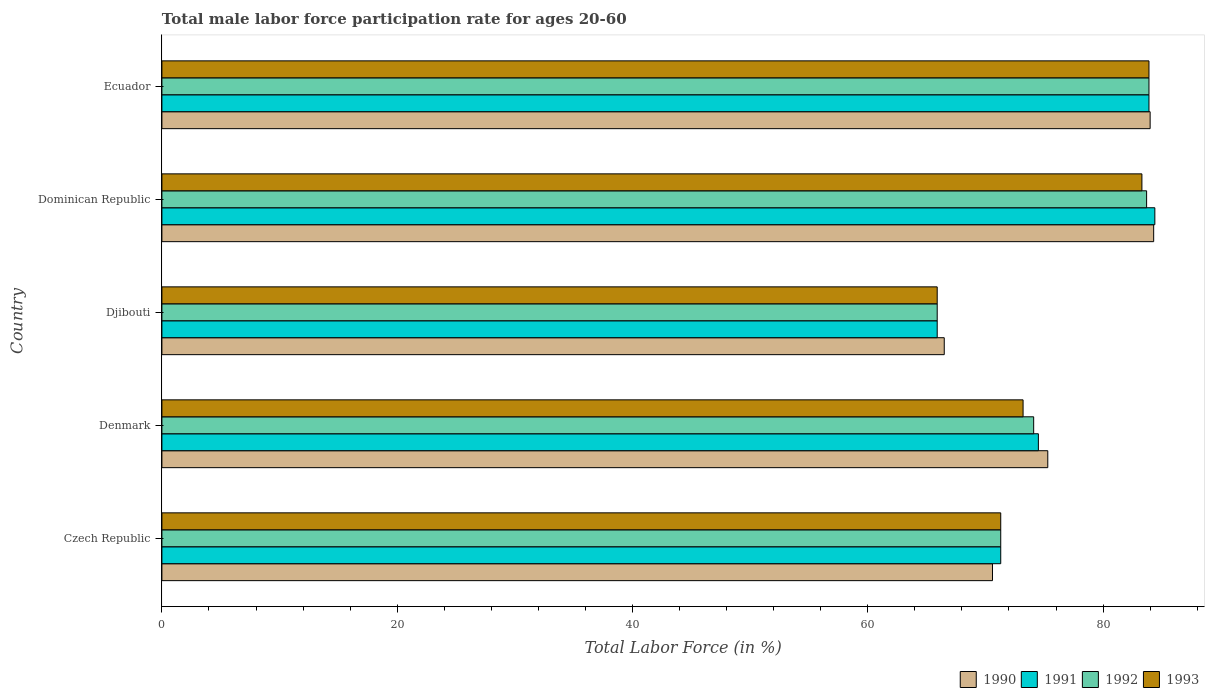Are the number of bars per tick equal to the number of legend labels?
Offer a very short reply. Yes. How many bars are there on the 3rd tick from the bottom?
Ensure brevity in your answer.  4. What is the male labor force participation rate in 1990 in Denmark?
Provide a succinct answer. 75.3. Across all countries, what is the maximum male labor force participation rate in 1991?
Your answer should be compact. 84.4. Across all countries, what is the minimum male labor force participation rate in 1992?
Give a very brief answer. 65.9. In which country was the male labor force participation rate in 1990 maximum?
Offer a terse response. Dominican Republic. In which country was the male labor force participation rate in 1991 minimum?
Make the answer very short. Djibouti. What is the total male labor force participation rate in 1993 in the graph?
Give a very brief answer. 377.6. What is the difference between the male labor force participation rate in 1993 in Dominican Republic and that in Ecuador?
Provide a succinct answer. -0.6. What is the difference between the male labor force participation rate in 1993 in Dominican Republic and the male labor force participation rate in 1990 in Czech Republic?
Make the answer very short. 12.7. What is the average male labor force participation rate in 1990 per country?
Ensure brevity in your answer.  76.14. What is the difference between the male labor force participation rate in 1991 and male labor force participation rate in 1993 in Dominican Republic?
Your answer should be compact. 1.1. What is the ratio of the male labor force participation rate in 1990 in Denmark to that in Dominican Republic?
Give a very brief answer. 0.89. Is the male labor force participation rate in 1992 in Djibouti less than that in Ecuador?
Offer a very short reply. Yes. Is the difference between the male labor force participation rate in 1991 in Dominican Republic and Ecuador greater than the difference between the male labor force participation rate in 1993 in Dominican Republic and Ecuador?
Offer a terse response. Yes. What is the difference between the highest and the second highest male labor force participation rate in 1991?
Offer a very short reply. 0.5. What is the difference between the highest and the lowest male labor force participation rate in 1992?
Ensure brevity in your answer.  18. In how many countries, is the male labor force participation rate in 1993 greater than the average male labor force participation rate in 1993 taken over all countries?
Offer a very short reply. 2. Is it the case that in every country, the sum of the male labor force participation rate in 1992 and male labor force participation rate in 1991 is greater than the sum of male labor force participation rate in 1993 and male labor force participation rate in 1990?
Your response must be concise. No. What does the 4th bar from the bottom in Ecuador represents?
Your answer should be compact. 1993. Is it the case that in every country, the sum of the male labor force participation rate in 1992 and male labor force participation rate in 1993 is greater than the male labor force participation rate in 1990?
Offer a terse response. Yes. How many countries are there in the graph?
Ensure brevity in your answer.  5. Where does the legend appear in the graph?
Provide a succinct answer. Bottom right. What is the title of the graph?
Your response must be concise. Total male labor force participation rate for ages 20-60. What is the label or title of the X-axis?
Provide a short and direct response. Total Labor Force (in %). What is the Total Labor Force (in %) of 1990 in Czech Republic?
Your response must be concise. 70.6. What is the Total Labor Force (in %) of 1991 in Czech Republic?
Offer a very short reply. 71.3. What is the Total Labor Force (in %) in 1992 in Czech Republic?
Your response must be concise. 71.3. What is the Total Labor Force (in %) in 1993 in Czech Republic?
Your answer should be compact. 71.3. What is the Total Labor Force (in %) of 1990 in Denmark?
Keep it short and to the point. 75.3. What is the Total Labor Force (in %) in 1991 in Denmark?
Offer a very short reply. 74.5. What is the Total Labor Force (in %) in 1992 in Denmark?
Give a very brief answer. 74.1. What is the Total Labor Force (in %) in 1993 in Denmark?
Your response must be concise. 73.2. What is the Total Labor Force (in %) in 1990 in Djibouti?
Offer a terse response. 66.5. What is the Total Labor Force (in %) in 1991 in Djibouti?
Give a very brief answer. 65.9. What is the Total Labor Force (in %) in 1992 in Djibouti?
Your response must be concise. 65.9. What is the Total Labor Force (in %) of 1993 in Djibouti?
Make the answer very short. 65.9. What is the Total Labor Force (in %) in 1990 in Dominican Republic?
Offer a very short reply. 84.3. What is the Total Labor Force (in %) in 1991 in Dominican Republic?
Give a very brief answer. 84.4. What is the Total Labor Force (in %) in 1992 in Dominican Republic?
Keep it short and to the point. 83.7. What is the Total Labor Force (in %) of 1993 in Dominican Republic?
Offer a very short reply. 83.3. What is the Total Labor Force (in %) of 1990 in Ecuador?
Give a very brief answer. 84. What is the Total Labor Force (in %) of 1991 in Ecuador?
Keep it short and to the point. 83.9. What is the Total Labor Force (in %) in 1992 in Ecuador?
Your response must be concise. 83.9. What is the Total Labor Force (in %) in 1993 in Ecuador?
Provide a short and direct response. 83.9. Across all countries, what is the maximum Total Labor Force (in %) of 1990?
Offer a terse response. 84.3. Across all countries, what is the maximum Total Labor Force (in %) in 1991?
Your answer should be very brief. 84.4. Across all countries, what is the maximum Total Labor Force (in %) of 1992?
Give a very brief answer. 83.9. Across all countries, what is the maximum Total Labor Force (in %) in 1993?
Offer a very short reply. 83.9. Across all countries, what is the minimum Total Labor Force (in %) of 1990?
Your answer should be compact. 66.5. Across all countries, what is the minimum Total Labor Force (in %) in 1991?
Offer a very short reply. 65.9. Across all countries, what is the minimum Total Labor Force (in %) in 1992?
Give a very brief answer. 65.9. Across all countries, what is the minimum Total Labor Force (in %) in 1993?
Make the answer very short. 65.9. What is the total Total Labor Force (in %) in 1990 in the graph?
Provide a short and direct response. 380.7. What is the total Total Labor Force (in %) of 1991 in the graph?
Your answer should be very brief. 380. What is the total Total Labor Force (in %) of 1992 in the graph?
Make the answer very short. 378.9. What is the total Total Labor Force (in %) of 1993 in the graph?
Provide a short and direct response. 377.6. What is the difference between the Total Labor Force (in %) of 1990 in Czech Republic and that in Denmark?
Provide a short and direct response. -4.7. What is the difference between the Total Labor Force (in %) in 1990 in Czech Republic and that in Djibouti?
Your response must be concise. 4.1. What is the difference between the Total Labor Force (in %) of 1992 in Czech Republic and that in Djibouti?
Your answer should be compact. 5.4. What is the difference between the Total Labor Force (in %) in 1993 in Czech Republic and that in Djibouti?
Keep it short and to the point. 5.4. What is the difference between the Total Labor Force (in %) in 1990 in Czech Republic and that in Dominican Republic?
Make the answer very short. -13.7. What is the difference between the Total Labor Force (in %) in 1993 in Czech Republic and that in Dominican Republic?
Offer a very short reply. -12. What is the difference between the Total Labor Force (in %) of 1992 in Czech Republic and that in Ecuador?
Your response must be concise. -12.6. What is the difference between the Total Labor Force (in %) in 1993 in Czech Republic and that in Ecuador?
Your answer should be very brief. -12.6. What is the difference between the Total Labor Force (in %) of 1992 in Denmark and that in Djibouti?
Ensure brevity in your answer.  8.2. What is the difference between the Total Labor Force (in %) of 1990 in Denmark and that in Dominican Republic?
Give a very brief answer. -9. What is the difference between the Total Labor Force (in %) of 1991 in Denmark and that in Dominican Republic?
Offer a very short reply. -9.9. What is the difference between the Total Labor Force (in %) of 1992 in Denmark and that in Dominican Republic?
Your answer should be very brief. -9.6. What is the difference between the Total Labor Force (in %) of 1993 in Denmark and that in Dominican Republic?
Offer a terse response. -10.1. What is the difference between the Total Labor Force (in %) in 1990 in Denmark and that in Ecuador?
Provide a succinct answer. -8.7. What is the difference between the Total Labor Force (in %) of 1992 in Denmark and that in Ecuador?
Provide a short and direct response. -9.8. What is the difference between the Total Labor Force (in %) in 1993 in Denmark and that in Ecuador?
Your answer should be very brief. -10.7. What is the difference between the Total Labor Force (in %) in 1990 in Djibouti and that in Dominican Republic?
Make the answer very short. -17.8. What is the difference between the Total Labor Force (in %) in 1991 in Djibouti and that in Dominican Republic?
Offer a terse response. -18.5. What is the difference between the Total Labor Force (in %) in 1992 in Djibouti and that in Dominican Republic?
Offer a very short reply. -17.8. What is the difference between the Total Labor Force (in %) of 1993 in Djibouti and that in Dominican Republic?
Provide a succinct answer. -17.4. What is the difference between the Total Labor Force (in %) of 1990 in Djibouti and that in Ecuador?
Keep it short and to the point. -17.5. What is the difference between the Total Labor Force (in %) of 1992 in Djibouti and that in Ecuador?
Give a very brief answer. -18. What is the difference between the Total Labor Force (in %) in 1993 in Djibouti and that in Ecuador?
Offer a terse response. -18. What is the difference between the Total Labor Force (in %) in 1990 in Dominican Republic and that in Ecuador?
Make the answer very short. 0.3. What is the difference between the Total Labor Force (in %) in 1991 in Dominican Republic and that in Ecuador?
Your answer should be very brief. 0.5. What is the difference between the Total Labor Force (in %) of 1990 in Czech Republic and the Total Labor Force (in %) of 1992 in Denmark?
Your answer should be very brief. -3.5. What is the difference between the Total Labor Force (in %) in 1991 in Czech Republic and the Total Labor Force (in %) in 1993 in Denmark?
Your answer should be compact. -1.9. What is the difference between the Total Labor Force (in %) of 1992 in Czech Republic and the Total Labor Force (in %) of 1993 in Denmark?
Your answer should be compact. -1.9. What is the difference between the Total Labor Force (in %) in 1990 in Czech Republic and the Total Labor Force (in %) in 1991 in Djibouti?
Make the answer very short. 4.7. What is the difference between the Total Labor Force (in %) in 1990 in Czech Republic and the Total Labor Force (in %) in 1992 in Djibouti?
Provide a short and direct response. 4.7. What is the difference between the Total Labor Force (in %) of 1990 in Czech Republic and the Total Labor Force (in %) of 1993 in Djibouti?
Make the answer very short. 4.7. What is the difference between the Total Labor Force (in %) of 1991 in Czech Republic and the Total Labor Force (in %) of 1992 in Djibouti?
Give a very brief answer. 5.4. What is the difference between the Total Labor Force (in %) of 1991 in Czech Republic and the Total Labor Force (in %) of 1993 in Djibouti?
Provide a short and direct response. 5.4. What is the difference between the Total Labor Force (in %) of 1992 in Czech Republic and the Total Labor Force (in %) of 1993 in Djibouti?
Make the answer very short. 5.4. What is the difference between the Total Labor Force (in %) of 1990 in Czech Republic and the Total Labor Force (in %) of 1992 in Dominican Republic?
Your response must be concise. -13.1. What is the difference between the Total Labor Force (in %) of 1991 in Czech Republic and the Total Labor Force (in %) of 1992 in Dominican Republic?
Make the answer very short. -12.4. What is the difference between the Total Labor Force (in %) of 1991 in Czech Republic and the Total Labor Force (in %) of 1993 in Dominican Republic?
Offer a terse response. -12. What is the difference between the Total Labor Force (in %) in 1990 in Czech Republic and the Total Labor Force (in %) in 1991 in Ecuador?
Make the answer very short. -13.3. What is the difference between the Total Labor Force (in %) in 1991 in Czech Republic and the Total Labor Force (in %) in 1992 in Ecuador?
Provide a short and direct response. -12.6. What is the difference between the Total Labor Force (in %) in 1990 in Denmark and the Total Labor Force (in %) in 1991 in Djibouti?
Your response must be concise. 9.4. What is the difference between the Total Labor Force (in %) in 1990 in Denmark and the Total Labor Force (in %) in 1992 in Dominican Republic?
Your response must be concise. -8.4. What is the difference between the Total Labor Force (in %) of 1991 in Denmark and the Total Labor Force (in %) of 1993 in Dominican Republic?
Ensure brevity in your answer.  -8.8. What is the difference between the Total Labor Force (in %) in 1992 in Denmark and the Total Labor Force (in %) in 1993 in Dominican Republic?
Provide a short and direct response. -9.2. What is the difference between the Total Labor Force (in %) of 1990 in Denmark and the Total Labor Force (in %) of 1993 in Ecuador?
Ensure brevity in your answer.  -8.6. What is the difference between the Total Labor Force (in %) in 1990 in Djibouti and the Total Labor Force (in %) in 1991 in Dominican Republic?
Provide a short and direct response. -17.9. What is the difference between the Total Labor Force (in %) of 1990 in Djibouti and the Total Labor Force (in %) of 1992 in Dominican Republic?
Your answer should be very brief. -17.2. What is the difference between the Total Labor Force (in %) in 1990 in Djibouti and the Total Labor Force (in %) in 1993 in Dominican Republic?
Offer a terse response. -16.8. What is the difference between the Total Labor Force (in %) in 1991 in Djibouti and the Total Labor Force (in %) in 1992 in Dominican Republic?
Your answer should be compact. -17.8. What is the difference between the Total Labor Force (in %) in 1991 in Djibouti and the Total Labor Force (in %) in 1993 in Dominican Republic?
Keep it short and to the point. -17.4. What is the difference between the Total Labor Force (in %) of 1992 in Djibouti and the Total Labor Force (in %) of 1993 in Dominican Republic?
Give a very brief answer. -17.4. What is the difference between the Total Labor Force (in %) in 1990 in Djibouti and the Total Labor Force (in %) in 1991 in Ecuador?
Ensure brevity in your answer.  -17.4. What is the difference between the Total Labor Force (in %) of 1990 in Djibouti and the Total Labor Force (in %) of 1992 in Ecuador?
Ensure brevity in your answer.  -17.4. What is the difference between the Total Labor Force (in %) in 1990 in Djibouti and the Total Labor Force (in %) in 1993 in Ecuador?
Keep it short and to the point. -17.4. What is the difference between the Total Labor Force (in %) in 1991 in Djibouti and the Total Labor Force (in %) in 1992 in Ecuador?
Your answer should be very brief. -18. What is the difference between the Total Labor Force (in %) in 1990 in Dominican Republic and the Total Labor Force (in %) in 1991 in Ecuador?
Offer a very short reply. 0.4. What is the difference between the Total Labor Force (in %) in 1990 in Dominican Republic and the Total Labor Force (in %) in 1992 in Ecuador?
Your answer should be very brief. 0.4. What is the difference between the Total Labor Force (in %) of 1990 in Dominican Republic and the Total Labor Force (in %) of 1993 in Ecuador?
Ensure brevity in your answer.  0.4. What is the average Total Labor Force (in %) in 1990 per country?
Provide a succinct answer. 76.14. What is the average Total Labor Force (in %) of 1992 per country?
Ensure brevity in your answer.  75.78. What is the average Total Labor Force (in %) of 1993 per country?
Offer a very short reply. 75.52. What is the difference between the Total Labor Force (in %) in 1990 and Total Labor Force (in %) in 1991 in Czech Republic?
Give a very brief answer. -0.7. What is the difference between the Total Labor Force (in %) in 1991 and Total Labor Force (in %) in 1993 in Czech Republic?
Offer a very short reply. 0. What is the difference between the Total Labor Force (in %) of 1990 and Total Labor Force (in %) of 1993 in Denmark?
Your response must be concise. 2.1. What is the difference between the Total Labor Force (in %) in 1991 and Total Labor Force (in %) in 1992 in Denmark?
Give a very brief answer. 0.4. What is the difference between the Total Labor Force (in %) of 1991 and Total Labor Force (in %) of 1993 in Denmark?
Your answer should be compact. 1.3. What is the difference between the Total Labor Force (in %) in 1990 and Total Labor Force (in %) in 1993 in Djibouti?
Offer a very short reply. 0.6. What is the difference between the Total Labor Force (in %) in 1991 and Total Labor Force (in %) in 1992 in Djibouti?
Your answer should be very brief. 0. What is the difference between the Total Labor Force (in %) of 1992 and Total Labor Force (in %) of 1993 in Djibouti?
Your response must be concise. 0. What is the difference between the Total Labor Force (in %) of 1990 and Total Labor Force (in %) of 1993 in Dominican Republic?
Make the answer very short. 1. What is the difference between the Total Labor Force (in %) in 1991 and Total Labor Force (in %) in 1993 in Dominican Republic?
Make the answer very short. 1.1. What is the difference between the Total Labor Force (in %) of 1992 and Total Labor Force (in %) of 1993 in Dominican Republic?
Make the answer very short. 0.4. What is the difference between the Total Labor Force (in %) in 1990 and Total Labor Force (in %) in 1992 in Ecuador?
Provide a succinct answer. 0.1. What is the difference between the Total Labor Force (in %) in 1991 and Total Labor Force (in %) in 1992 in Ecuador?
Offer a terse response. 0. What is the difference between the Total Labor Force (in %) of 1991 and Total Labor Force (in %) of 1993 in Ecuador?
Your answer should be very brief. 0. What is the difference between the Total Labor Force (in %) of 1992 and Total Labor Force (in %) of 1993 in Ecuador?
Give a very brief answer. 0. What is the ratio of the Total Labor Force (in %) in 1990 in Czech Republic to that in Denmark?
Your answer should be compact. 0.94. What is the ratio of the Total Labor Force (in %) of 1992 in Czech Republic to that in Denmark?
Your response must be concise. 0.96. What is the ratio of the Total Labor Force (in %) in 1990 in Czech Republic to that in Djibouti?
Your answer should be compact. 1.06. What is the ratio of the Total Labor Force (in %) in 1991 in Czech Republic to that in Djibouti?
Provide a short and direct response. 1.08. What is the ratio of the Total Labor Force (in %) of 1992 in Czech Republic to that in Djibouti?
Your response must be concise. 1.08. What is the ratio of the Total Labor Force (in %) of 1993 in Czech Republic to that in Djibouti?
Your answer should be very brief. 1.08. What is the ratio of the Total Labor Force (in %) in 1990 in Czech Republic to that in Dominican Republic?
Offer a terse response. 0.84. What is the ratio of the Total Labor Force (in %) of 1991 in Czech Republic to that in Dominican Republic?
Provide a succinct answer. 0.84. What is the ratio of the Total Labor Force (in %) of 1992 in Czech Republic to that in Dominican Republic?
Offer a terse response. 0.85. What is the ratio of the Total Labor Force (in %) of 1993 in Czech Republic to that in Dominican Republic?
Give a very brief answer. 0.86. What is the ratio of the Total Labor Force (in %) in 1990 in Czech Republic to that in Ecuador?
Give a very brief answer. 0.84. What is the ratio of the Total Labor Force (in %) in 1991 in Czech Republic to that in Ecuador?
Provide a short and direct response. 0.85. What is the ratio of the Total Labor Force (in %) of 1992 in Czech Republic to that in Ecuador?
Offer a very short reply. 0.85. What is the ratio of the Total Labor Force (in %) of 1993 in Czech Republic to that in Ecuador?
Your answer should be compact. 0.85. What is the ratio of the Total Labor Force (in %) of 1990 in Denmark to that in Djibouti?
Make the answer very short. 1.13. What is the ratio of the Total Labor Force (in %) of 1991 in Denmark to that in Djibouti?
Your answer should be compact. 1.13. What is the ratio of the Total Labor Force (in %) of 1992 in Denmark to that in Djibouti?
Your answer should be very brief. 1.12. What is the ratio of the Total Labor Force (in %) of 1993 in Denmark to that in Djibouti?
Offer a very short reply. 1.11. What is the ratio of the Total Labor Force (in %) in 1990 in Denmark to that in Dominican Republic?
Your answer should be very brief. 0.89. What is the ratio of the Total Labor Force (in %) of 1991 in Denmark to that in Dominican Republic?
Your response must be concise. 0.88. What is the ratio of the Total Labor Force (in %) in 1992 in Denmark to that in Dominican Republic?
Make the answer very short. 0.89. What is the ratio of the Total Labor Force (in %) in 1993 in Denmark to that in Dominican Republic?
Keep it short and to the point. 0.88. What is the ratio of the Total Labor Force (in %) of 1990 in Denmark to that in Ecuador?
Make the answer very short. 0.9. What is the ratio of the Total Labor Force (in %) of 1991 in Denmark to that in Ecuador?
Keep it short and to the point. 0.89. What is the ratio of the Total Labor Force (in %) of 1992 in Denmark to that in Ecuador?
Provide a short and direct response. 0.88. What is the ratio of the Total Labor Force (in %) of 1993 in Denmark to that in Ecuador?
Provide a short and direct response. 0.87. What is the ratio of the Total Labor Force (in %) in 1990 in Djibouti to that in Dominican Republic?
Keep it short and to the point. 0.79. What is the ratio of the Total Labor Force (in %) in 1991 in Djibouti to that in Dominican Republic?
Make the answer very short. 0.78. What is the ratio of the Total Labor Force (in %) in 1992 in Djibouti to that in Dominican Republic?
Give a very brief answer. 0.79. What is the ratio of the Total Labor Force (in %) of 1993 in Djibouti to that in Dominican Republic?
Your answer should be compact. 0.79. What is the ratio of the Total Labor Force (in %) of 1990 in Djibouti to that in Ecuador?
Ensure brevity in your answer.  0.79. What is the ratio of the Total Labor Force (in %) in 1991 in Djibouti to that in Ecuador?
Your answer should be compact. 0.79. What is the ratio of the Total Labor Force (in %) in 1992 in Djibouti to that in Ecuador?
Keep it short and to the point. 0.79. What is the ratio of the Total Labor Force (in %) in 1993 in Djibouti to that in Ecuador?
Make the answer very short. 0.79. What is the ratio of the Total Labor Force (in %) in 1993 in Dominican Republic to that in Ecuador?
Your answer should be very brief. 0.99. What is the difference between the highest and the second highest Total Labor Force (in %) in 1991?
Provide a succinct answer. 0.5. What is the difference between the highest and the second highest Total Labor Force (in %) in 1993?
Give a very brief answer. 0.6. What is the difference between the highest and the lowest Total Labor Force (in %) of 1991?
Make the answer very short. 18.5. What is the difference between the highest and the lowest Total Labor Force (in %) in 1992?
Your response must be concise. 18. 